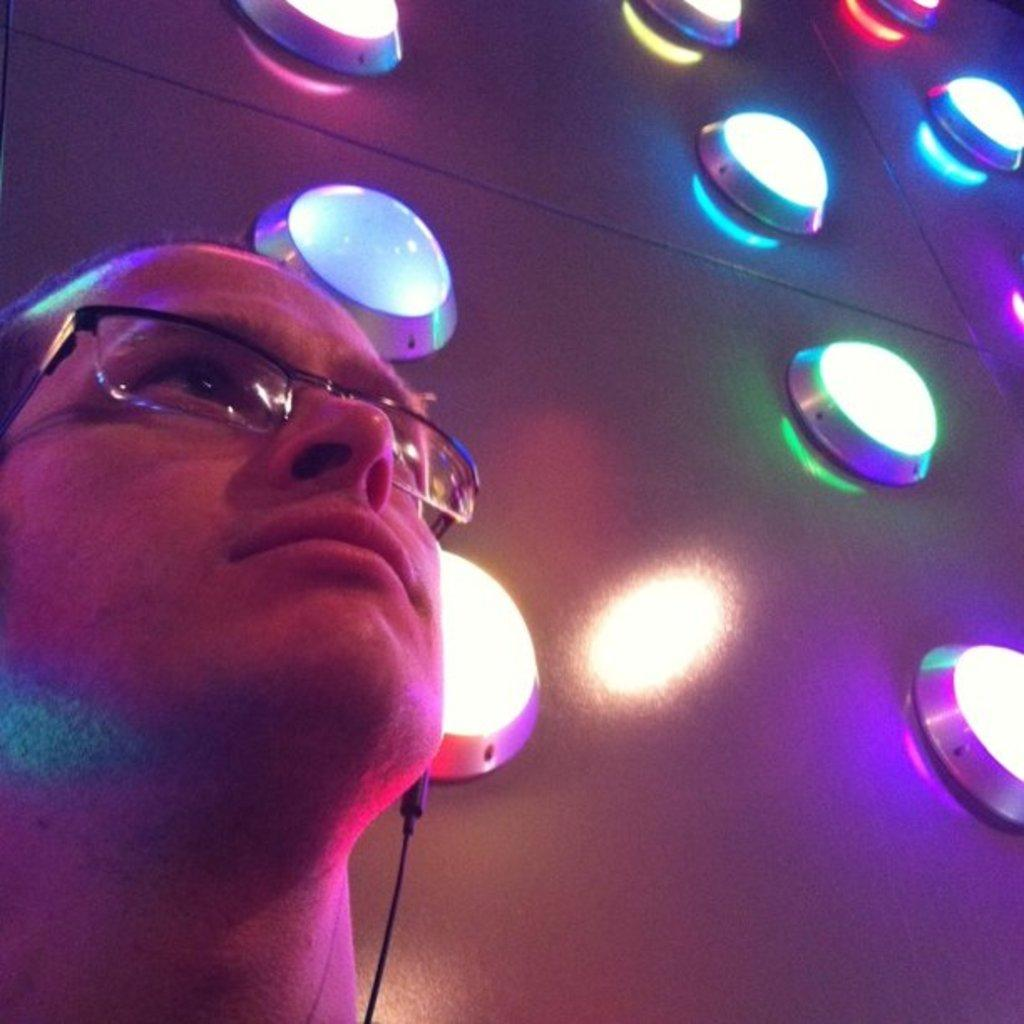Who is present in the image? There is a man in the image. Where is the man located in the image? The man is on the left side of the image. What is the man wearing in the image? The man is wearing spectacles in the image. What other decorative elements can be seen in the image? There are decorative lights in the image. Where are the decorative lights located in the image? The decorative lights are on the right side of the image. What type of eggnog is the scarecrow drinking in the image? There is no scarecrow or eggnog present in the image. Who is the daughter of the man in the image? There is no mention of a daughter in the image or the provided facts. 